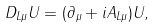Convert formula to latex. <formula><loc_0><loc_0><loc_500><loc_500>D _ { L \mu } U = ( \partial _ { \mu } + i A _ { L \mu } ) U ,</formula> 